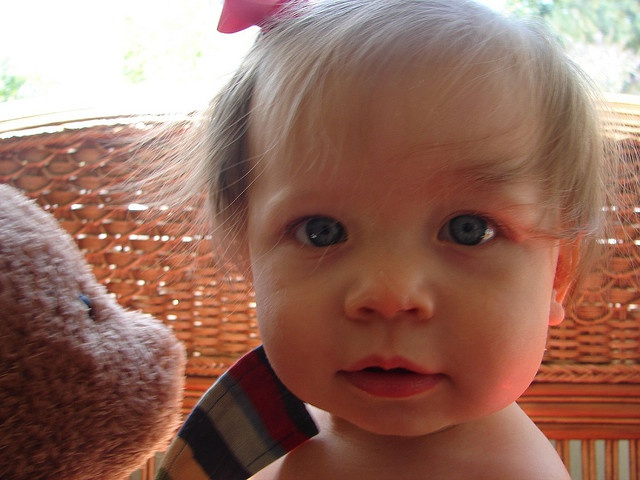Describe the objects in this image and their specific colors. I can see people in white, brown, and maroon tones, bench in white and brown tones, and teddy bear in white, maroon, black, gray, and darkgray tones in this image. 